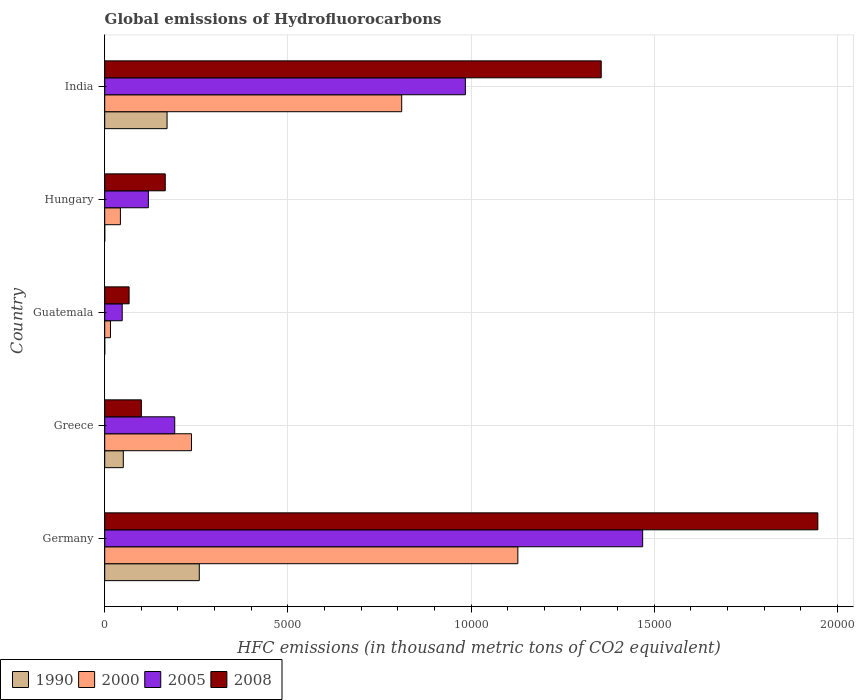How many different coloured bars are there?
Provide a succinct answer. 4. How many groups of bars are there?
Offer a very short reply. 5. What is the global emissions of Hydrofluorocarbons in 2005 in India?
Keep it short and to the point. 9845.2. Across all countries, what is the maximum global emissions of Hydrofluorocarbons in 1990?
Make the answer very short. 2581.5. In which country was the global emissions of Hydrofluorocarbons in 2005 maximum?
Offer a very short reply. Germany. In which country was the global emissions of Hydrofluorocarbons in 2005 minimum?
Offer a terse response. Guatemala. What is the total global emissions of Hydrofluorocarbons in 2008 in the graph?
Offer a terse response. 3.63e+04. What is the difference between the global emissions of Hydrofluorocarbons in 1990 in Guatemala and that in India?
Your answer should be compact. -1702. What is the difference between the global emissions of Hydrofluorocarbons in 2008 in Greece and the global emissions of Hydrofluorocarbons in 2000 in Guatemala?
Ensure brevity in your answer.  842.7. What is the average global emissions of Hydrofluorocarbons in 2005 per country?
Give a very brief answer. 5622.08. What is the difference between the global emissions of Hydrofluorocarbons in 1990 and global emissions of Hydrofluorocarbons in 2008 in Guatemala?
Offer a terse response. -665.7. What is the ratio of the global emissions of Hydrofluorocarbons in 2000 in Germany to that in India?
Offer a terse response. 1.39. Is the global emissions of Hydrofluorocarbons in 2000 in Greece less than that in India?
Offer a very short reply. Yes. Is the difference between the global emissions of Hydrofluorocarbons in 1990 in Germany and India greater than the difference between the global emissions of Hydrofluorocarbons in 2008 in Germany and India?
Your answer should be very brief. No. What is the difference between the highest and the second highest global emissions of Hydrofluorocarbons in 1990?
Give a very brief answer. 879.4. What is the difference between the highest and the lowest global emissions of Hydrofluorocarbons in 2008?
Your answer should be very brief. 1.88e+04. In how many countries, is the global emissions of Hydrofluorocarbons in 2005 greater than the average global emissions of Hydrofluorocarbons in 2005 taken over all countries?
Your answer should be very brief. 2. Is the sum of the global emissions of Hydrofluorocarbons in 2005 in Germany and Greece greater than the maximum global emissions of Hydrofluorocarbons in 1990 across all countries?
Keep it short and to the point. Yes. Is it the case that in every country, the sum of the global emissions of Hydrofluorocarbons in 2000 and global emissions of Hydrofluorocarbons in 1990 is greater than the sum of global emissions of Hydrofluorocarbons in 2008 and global emissions of Hydrofluorocarbons in 2005?
Provide a short and direct response. No. What does the 4th bar from the top in Germany represents?
Offer a terse response. 1990. What does the 1st bar from the bottom in India represents?
Keep it short and to the point. 1990. Is it the case that in every country, the sum of the global emissions of Hydrofluorocarbons in 1990 and global emissions of Hydrofluorocarbons in 2005 is greater than the global emissions of Hydrofluorocarbons in 2000?
Keep it short and to the point. Yes. Are all the bars in the graph horizontal?
Offer a terse response. Yes. How many countries are there in the graph?
Offer a terse response. 5. Are the values on the major ticks of X-axis written in scientific E-notation?
Your answer should be very brief. No. Does the graph contain any zero values?
Your answer should be compact. No. Does the graph contain grids?
Keep it short and to the point. Yes. Where does the legend appear in the graph?
Your answer should be compact. Bottom left. How are the legend labels stacked?
Ensure brevity in your answer.  Horizontal. What is the title of the graph?
Make the answer very short. Global emissions of Hydrofluorocarbons. Does "2015" appear as one of the legend labels in the graph?
Keep it short and to the point. No. What is the label or title of the X-axis?
Give a very brief answer. HFC emissions (in thousand metric tons of CO2 equivalent). What is the label or title of the Y-axis?
Ensure brevity in your answer.  Country. What is the HFC emissions (in thousand metric tons of CO2 equivalent) of 1990 in Germany?
Make the answer very short. 2581.5. What is the HFC emissions (in thousand metric tons of CO2 equivalent) of 2000 in Germany?
Provide a short and direct response. 1.13e+04. What is the HFC emissions (in thousand metric tons of CO2 equivalent) of 2005 in Germany?
Ensure brevity in your answer.  1.47e+04. What is the HFC emissions (in thousand metric tons of CO2 equivalent) of 2008 in Germany?
Offer a terse response. 1.95e+04. What is the HFC emissions (in thousand metric tons of CO2 equivalent) in 1990 in Greece?
Ensure brevity in your answer.  507.2. What is the HFC emissions (in thousand metric tons of CO2 equivalent) of 2000 in Greece?
Give a very brief answer. 2368.4. What is the HFC emissions (in thousand metric tons of CO2 equivalent) of 2005 in Greece?
Ensure brevity in your answer.  1911.4. What is the HFC emissions (in thousand metric tons of CO2 equivalent) of 2008 in Greece?
Give a very brief answer. 1000.3. What is the HFC emissions (in thousand metric tons of CO2 equivalent) of 1990 in Guatemala?
Your answer should be compact. 0.1. What is the HFC emissions (in thousand metric tons of CO2 equivalent) of 2000 in Guatemala?
Your response must be concise. 157.6. What is the HFC emissions (in thousand metric tons of CO2 equivalent) in 2005 in Guatemala?
Make the answer very short. 477.8. What is the HFC emissions (in thousand metric tons of CO2 equivalent) of 2008 in Guatemala?
Keep it short and to the point. 665.8. What is the HFC emissions (in thousand metric tons of CO2 equivalent) of 2000 in Hungary?
Your answer should be very brief. 428.2. What is the HFC emissions (in thousand metric tons of CO2 equivalent) in 2005 in Hungary?
Offer a terse response. 1191.4. What is the HFC emissions (in thousand metric tons of CO2 equivalent) of 2008 in Hungary?
Your answer should be compact. 1652.9. What is the HFC emissions (in thousand metric tons of CO2 equivalent) in 1990 in India?
Provide a succinct answer. 1702.1. What is the HFC emissions (in thousand metric tons of CO2 equivalent) of 2000 in India?
Your answer should be compact. 8107.2. What is the HFC emissions (in thousand metric tons of CO2 equivalent) of 2005 in India?
Provide a short and direct response. 9845.2. What is the HFC emissions (in thousand metric tons of CO2 equivalent) in 2008 in India?
Offer a very short reply. 1.36e+04. Across all countries, what is the maximum HFC emissions (in thousand metric tons of CO2 equivalent) in 1990?
Your answer should be compact. 2581.5. Across all countries, what is the maximum HFC emissions (in thousand metric tons of CO2 equivalent) in 2000?
Give a very brief answer. 1.13e+04. Across all countries, what is the maximum HFC emissions (in thousand metric tons of CO2 equivalent) in 2005?
Ensure brevity in your answer.  1.47e+04. Across all countries, what is the maximum HFC emissions (in thousand metric tons of CO2 equivalent) in 2008?
Provide a succinct answer. 1.95e+04. Across all countries, what is the minimum HFC emissions (in thousand metric tons of CO2 equivalent) in 2000?
Your response must be concise. 157.6. Across all countries, what is the minimum HFC emissions (in thousand metric tons of CO2 equivalent) in 2005?
Ensure brevity in your answer.  477.8. Across all countries, what is the minimum HFC emissions (in thousand metric tons of CO2 equivalent) in 2008?
Offer a terse response. 665.8. What is the total HFC emissions (in thousand metric tons of CO2 equivalent) in 1990 in the graph?
Keep it short and to the point. 4791. What is the total HFC emissions (in thousand metric tons of CO2 equivalent) of 2000 in the graph?
Your answer should be very brief. 2.23e+04. What is the total HFC emissions (in thousand metric tons of CO2 equivalent) of 2005 in the graph?
Ensure brevity in your answer.  2.81e+04. What is the total HFC emissions (in thousand metric tons of CO2 equivalent) in 2008 in the graph?
Your response must be concise. 3.63e+04. What is the difference between the HFC emissions (in thousand metric tons of CO2 equivalent) in 1990 in Germany and that in Greece?
Your answer should be compact. 2074.3. What is the difference between the HFC emissions (in thousand metric tons of CO2 equivalent) in 2000 in Germany and that in Greece?
Keep it short and to the point. 8909.2. What is the difference between the HFC emissions (in thousand metric tons of CO2 equivalent) in 2005 in Germany and that in Greece?
Offer a terse response. 1.28e+04. What is the difference between the HFC emissions (in thousand metric tons of CO2 equivalent) in 2008 in Germany and that in Greece?
Keep it short and to the point. 1.85e+04. What is the difference between the HFC emissions (in thousand metric tons of CO2 equivalent) in 1990 in Germany and that in Guatemala?
Offer a terse response. 2581.4. What is the difference between the HFC emissions (in thousand metric tons of CO2 equivalent) of 2000 in Germany and that in Guatemala?
Your answer should be compact. 1.11e+04. What is the difference between the HFC emissions (in thousand metric tons of CO2 equivalent) of 2005 in Germany and that in Guatemala?
Ensure brevity in your answer.  1.42e+04. What is the difference between the HFC emissions (in thousand metric tons of CO2 equivalent) of 2008 in Germany and that in Guatemala?
Make the answer very short. 1.88e+04. What is the difference between the HFC emissions (in thousand metric tons of CO2 equivalent) of 1990 in Germany and that in Hungary?
Your answer should be compact. 2581.4. What is the difference between the HFC emissions (in thousand metric tons of CO2 equivalent) in 2000 in Germany and that in Hungary?
Offer a terse response. 1.08e+04. What is the difference between the HFC emissions (in thousand metric tons of CO2 equivalent) in 2005 in Germany and that in Hungary?
Your answer should be very brief. 1.35e+04. What is the difference between the HFC emissions (in thousand metric tons of CO2 equivalent) of 2008 in Germany and that in Hungary?
Your response must be concise. 1.78e+04. What is the difference between the HFC emissions (in thousand metric tons of CO2 equivalent) in 1990 in Germany and that in India?
Your response must be concise. 879.4. What is the difference between the HFC emissions (in thousand metric tons of CO2 equivalent) of 2000 in Germany and that in India?
Your response must be concise. 3170.4. What is the difference between the HFC emissions (in thousand metric tons of CO2 equivalent) of 2005 in Germany and that in India?
Provide a short and direct response. 4839.4. What is the difference between the HFC emissions (in thousand metric tons of CO2 equivalent) of 2008 in Germany and that in India?
Provide a succinct answer. 5913.1. What is the difference between the HFC emissions (in thousand metric tons of CO2 equivalent) of 1990 in Greece and that in Guatemala?
Make the answer very short. 507.1. What is the difference between the HFC emissions (in thousand metric tons of CO2 equivalent) of 2000 in Greece and that in Guatemala?
Your response must be concise. 2210.8. What is the difference between the HFC emissions (in thousand metric tons of CO2 equivalent) in 2005 in Greece and that in Guatemala?
Ensure brevity in your answer.  1433.6. What is the difference between the HFC emissions (in thousand metric tons of CO2 equivalent) in 2008 in Greece and that in Guatemala?
Provide a short and direct response. 334.5. What is the difference between the HFC emissions (in thousand metric tons of CO2 equivalent) in 1990 in Greece and that in Hungary?
Provide a short and direct response. 507.1. What is the difference between the HFC emissions (in thousand metric tons of CO2 equivalent) of 2000 in Greece and that in Hungary?
Your answer should be compact. 1940.2. What is the difference between the HFC emissions (in thousand metric tons of CO2 equivalent) in 2005 in Greece and that in Hungary?
Provide a short and direct response. 720. What is the difference between the HFC emissions (in thousand metric tons of CO2 equivalent) of 2008 in Greece and that in Hungary?
Provide a succinct answer. -652.6. What is the difference between the HFC emissions (in thousand metric tons of CO2 equivalent) in 1990 in Greece and that in India?
Your answer should be very brief. -1194.9. What is the difference between the HFC emissions (in thousand metric tons of CO2 equivalent) of 2000 in Greece and that in India?
Your answer should be compact. -5738.8. What is the difference between the HFC emissions (in thousand metric tons of CO2 equivalent) in 2005 in Greece and that in India?
Offer a terse response. -7933.8. What is the difference between the HFC emissions (in thousand metric tons of CO2 equivalent) of 2008 in Greece and that in India?
Your response must be concise. -1.26e+04. What is the difference between the HFC emissions (in thousand metric tons of CO2 equivalent) of 1990 in Guatemala and that in Hungary?
Provide a succinct answer. 0. What is the difference between the HFC emissions (in thousand metric tons of CO2 equivalent) in 2000 in Guatemala and that in Hungary?
Make the answer very short. -270.6. What is the difference between the HFC emissions (in thousand metric tons of CO2 equivalent) in 2005 in Guatemala and that in Hungary?
Ensure brevity in your answer.  -713.6. What is the difference between the HFC emissions (in thousand metric tons of CO2 equivalent) in 2008 in Guatemala and that in Hungary?
Provide a short and direct response. -987.1. What is the difference between the HFC emissions (in thousand metric tons of CO2 equivalent) of 1990 in Guatemala and that in India?
Ensure brevity in your answer.  -1702. What is the difference between the HFC emissions (in thousand metric tons of CO2 equivalent) in 2000 in Guatemala and that in India?
Ensure brevity in your answer.  -7949.6. What is the difference between the HFC emissions (in thousand metric tons of CO2 equivalent) of 2005 in Guatemala and that in India?
Your answer should be very brief. -9367.4. What is the difference between the HFC emissions (in thousand metric tons of CO2 equivalent) of 2008 in Guatemala and that in India?
Offer a very short reply. -1.29e+04. What is the difference between the HFC emissions (in thousand metric tons of CO2 equivalent) in 1990 in Hungary and that in India?
Offer a terse response. -1702. What is the difference between the HFC emissions (in thousand metric tons of CO2 equivalent) in 2000 in Hungary and that in India?
Provide a succinct answer. -7679. What is the difference between the HFC emissions (in thousand metric tons of CO2 equivalent) in 2005 in Hungary and that in India?
Your response must be concise. -8653.8. What is the difference between the HFC emissions (in thousand metric tons of CO2 equivalent) of 2008 in Hungary and that in India?
Your answer should be compact. -1.19e+04. What is the difference between the HFC emissions (in thousand metric tons of CO2 equivalent) of 1990 in Germany and the HFC emissions (in thousand metric tons of CO2 equivalent) of 2000 in Greece?
Make the answer very short. 213.1. What is the difference between the HFC emissions (in thousand metric tons of CO2 equivalent) of 1990 in Germany and the HFC emissions (in thousand metric tons of CO2 equivalent) of 2005 in Greece?
Ensure brevity in your answer.  670.1. What is the difference between the HFC emissions (in thousand metric tons of CO2 equivalent) in 1990 in Germany and the HFC emissions (in thousand metric tons of CO2 equivalent) in 2008 in Greece?
Offer a terse response. 1581.2. What is the difference between the HFC emissions (in thousand metric tons of CO2 equivalent) in 2000 in Germany and the HFC emissions (in thousand metric tons of CO2 equivalent) in 2005 in Greece?
Ensure brevity in your answer.  9366.2. What is the difference between the HFC emissions (in thousand metric tons of CO2 equivalent) of 2000 in Germany and the HFC emissions (in thousand metric tons of CO2 equivalent) of 2008 in Greece?
Your answer should be compact. 1.03e+04. What is the difference between the HFC emissions (in thousand metric tons of CO2 equivalent) in 2005 in Germany and the HFC emissions (in thousand metric tons of CO2 equivalent) in 2008 in Greece?
Your answer should be very brief. 1.37e+04. What is the difference between the HFC emissions (in thousand metric tons of CO2 equivalent) in 1990 in Germany and the HFC emissions (in thousand metric tons of CO2 equivalent) in 2000 in Guatemala?
Your answer should be very brief. 2423.9. What is the difference between the HFC emissions (in thousand metric tons of CO2 equivalent) of 1990 in Germany and the HFC emissions (in thousand metric tons of CO2 equivalent) of 2005 in Guatemala?
Give a very brief answer. 2103.7. What is the difference between the HFC emissions (in thousand metric tons of CO2 equivalent) in 1990 in Germany and the HFC emissions (in thousand metric tons of CO2 equivalent) in 2008 in Guatemala?
Keep it short and to the point. 1915.7. What is the difference between the HFC emissions (in thousand metric tons of CO2 equivalent) of 2000 in Germany and the HFC emissions (in thousand metric tons of CO2 equivalent) of 2005 in Guatemala?
Provide a short and direct response. 1.08e+04. What is the difference between the HFC emissions (in thousand metric tons of CO2 equivalent) of 2000 in Germany and the HFC emissions (in thousand metric tons of CO2 equivalent) of 2008 in Guatemala?
Your response must be concise. 1.06e+04. What is the difference between the HFC emissions (in thousand metric tons of CO2 equivalent) of 2005 in Germany and the HFC emissions (in thousand metric tons of CO2 equivalent) of 2008 in Guatemala?
Offer a very short reply. 1.40e+04. What is the difference between the HFC emissions (in thousand metric tons of CO2 equivalent) in 1990 in Germany and the HFC emissions (in thousand metric tons of CO2 equivalent) in 2000 in Hungary?
Make the answer very short. 2153.3. What is the difference between the HFC emissions (in thousand metric tons of CO2 equivalent) in 1990 in Germany and the HFC emissions (in thousand metric tons of CO2 equivalent) in 2005 in Hungary?
Provide a short and direct response. 1390.1. What is the difference between the HFC emissions (in thousand metric tons of CO2 equivalent) of 1990 in Germany and the HFC emissions (in thousand metric tons of CO2 equivalent) of 2008 in Hungary?
Offer a very short reply. 928.6. What is the difference between the HFC emissions (in thousand metric tons of CO2 equivalent) in 2000 in Germany and the HFC emissions (in thousand metric tons of CO2 equivalent) in 2005 in Hungary?
Ensure brevity in your answer.  1.01e+04. What is the difference between the HFC emissions (in thousand metric tons of CO2 equivalent) of 2000 in Germany and the HFC emissions (in thousand metric tons of CO2 equivalent) of 2008 in Hungary?
Your response must be concise. 9624.7. What is the difference between the HFC emissions (in thousand metric tons of CO2 equivalent) in 2005 in Germany and the HFC emissions (in thousand metric tons of CO2 equivalent) in 2008 in Hungary?
Provide a succinct answer. 1.30e+04. What is the difference between the HFC emissions (in thousand metric tons of CO2 equivalent) in 1990 in Germany and the HFC emissions (in thousand metric tons of CO2 equivalent) in 2000 in India?
Offer a terse response. -5525.7. What is the difference between the HFC emissions (in thousand metric tons of CO2 equivalent) of 1990 in Germany and the HFC emissions (in thousand metric tons of CO2 equivalent) of 2005 in India?
Provide a succinct answer. -7263.7. What is the difference between the HFC emissions (in thousand metric tons of CO2 equivalent) in 1990 in Germany and the HFC emissions (in thousand metric tons of CO2 equivalent) in 2008 in India?
Make the answer very short. -1.10e+04. What is the difference between the HFC emissions (in thousand metric tons of CO2 equivalent) of 2000 in Germany and the HFC emissions (in thousand metric tons of CO2 equivalent) of 2005 in India?
Provide a succinct answer. 1432.4. What is the difference between the HFC emissions (in thousand metric tons of CO2 equivalent) of 2000 in Germany and the HFC emissions (in thousand metric tons of CO2 equivalent) of 2008 in India?
Your answer should be compact. -2276.1. What is the difference between the HFC emissions (in thousand metric tons of CO2 equivalent) in 2005 in Germany and the HFC emissions (in thousand metric tons of CO2 equivalent) in 2008 in India?
Your answer should be compact. 1130.9. What is the difference between the HFC emissions (in thousand metric tons of CO2 equivalent) of 1990 in Greece and the HFC emissions (in thousand metric tons of CO2 equivalent) of 2000 in Guatemala?
Ensure brevity in your answer.  349.6. What is the difference between the HFC emissions (in thousand metric tons of CO2 equivalent) in 1990 in Greece and the HFC emissions (in thousand metric tons of CO2 equivalent) in 2005 in Guatemala?
Your answer should be very brief. 29.4. What is the difference between the HFC emissions (in thousand metric tons of CO2 equivalent) in 1990 in Greece and the HFC emissions (in thousand metric tons of CO2 equivalent) in 2008 in Guatemala?
Give a very brief answer. -158.6. What is the difference between the HFC emissions (in thousand metric tons of CO2 equivalent) in 2000 in Greece and the HFC emissions (in thousand metric tons of CO2 equivalent) in 2005 in Guatemala?
Your response must be concise. 1890.6. What is the difference between the HFC emissions (in thousand metric tons of CO2 equivalent) of 2000 in Greece and the HFC emissions (in thousand metric tons of CO2 equivalent) of 2008 in Guatemala?
Your answer should be very brief. 1702.6. What is the difference between the HFC emissions (in thousand metric tons of CO2 equivalent) of 2005 in Greece and the HFC emissions (in thousand metric tons of CO2 equivalent) of 2008 in Guatemala?
Your answer should be compact. 1245.6. What is the difference between the HFC emissions (in thousand metric tons of CO2 equivalent) in 1990 in Greece and the HFC emissions (in thousand metric tons of CO2 equivalent) in 2000 in Hungary?
Offer a terse response. 79. What is the difference between the HFC emissions (in thousand metric tons of CO2 equivalent) of 1990 in Greece and the HFC emissions (in thousand metric tons of CO2 equivalent) of 2005 in Hungary?
Make the answer very short. -684.2. What is the difference between the HFC emissions (in thousand metric tons of CO2 equivalent) of 1990 in Greece and the HFC emissions (in thousand metric tons of CO2 equivalent) of 2008 in Hungary?
Provide a short and direct response. -1145.7. What is the difference between the HFC emissions (in thousand metric tons of CO2 equivalent) in 2000 in Greece and the HFC emissions (in thousand metric tons of CO2 equivalent) in 2005 in Hungary?
Your answer should be compact. 1177. What is the difference between the HFC emissions (in thousand metric tons of CO2 equivalent) in 2000 in Greece and the HFC emissions (in thousand metric tons of CO2 equivalent) in 2008 in Hungary?
Keep it short and to the point. 715.5. What is the difference between the HFC emissions (in thousand metric tons of CO2 equivalent) of 2005 in Greece and the HFC emissions (in thousand metric tons of CO2 equivalent) of 2008 in Hungary?
Make the answer very short. 258.5. What is the difference between the HFC emissions (in thousand metric tons of CO2 equivalent) in 1990 in Greece and the HFC emissions (in thousand metric tons of CO2 equivalent) in 2000 in India?
Offer a terse response. -7600. What is the difference between the HFC emissions (in thousand metric tons of CO2 equivalent) of 1990 in Greece and the HFC emissions (in thousand metric tons of CO2 equivalent) of 2005 in India?
Ensure brevity in your answer.  -9338. What is the difference between the HFC emissions (in thousand metric tons of CO2 equivalent) of 1990 in Greece and the HFC emissions (in thousand metric tons of CO2 equivalent) of 2008 in India?
Offer a very short reply. -1.30e+04. What is the difference between the HFC emissions (in thousand metric tons of CO2 equivalent) of 2000 in Greece and the HFC emissions (in thousand metric tons of CO2 equivalent) of 2005 in India?
Give a very brief answer. -7476.8. What is the difference between the HFC emissions (in thousand metric tons of CO2 equivalent) of 2000 in Greece and the HFC emissions (in thousand metric tons of CO2 equivalent) of 2008 in India?
Your answer should be compact. -1.12e+04. What is the difference between the HFC emissions (in thousand metric tons of CO2 equivalent) of 2005 in Greece and the HFC emissions (in thousand metric tons of CO2 equivalent) of 2008 in India?
Offer a very short reply. -1.16e+04. What is the difference between the HFC emissions (in thousand metric tons of CO2 equivalent) in 1990 in Guatemala and the HFC emissions (in thousand metric tons of CO2 equivalent) in 2000 in Hungary?
Keep it short and to the point. -428.1. What is the difference between the HFC emissions (in thousand metric tons of CO2 equivalent) in 1990 in Guatemala and the HFC emissions (in thousand metric tons of CO2 equivalent) in 2005 in Hungary?
Provide a succinct answer. -1191.3. What is the difference between the HFC emissions (in thousand metric tons of CO2 equivalent) of 1990 in Guatemala and the HFC emissions (in thousand metric tons of CO2 equivalent) of 2008 in Hungary?
Ensure brevity in your answer.  -1652.8. What is the difference between the HFC emissions (in thousand metric tons of CO2 equivalent) in 2000 in Guatemala and the HFC emissions (in thousand metric tons of CO2 equivalent) in 2005 in Hungary?
Make the answer very short. -1033.8. What is the difference between the HFC emissions (in thousand metric tons of CO2 equivalent) of 2000 in Guatemala and the HFC emissions (in thousand metric tons of CO2 equivalent) of 2008 in Hungary?
Your response must be concise. -1495.3. What is the difference between the HFC emissions (in thousand metric tons of CO2 equivalent) in 2005 in Guatemala and the HFC emissions (in thousand metric tons of CO2 equivalent) in 2008 in Hungary?
Your answer should be very brief. -1175.1. What is the difference between the HFC emissions (in thousand metric tons of CO2 equivalent) in 1990 in Guatemala and the HFC emissions (in thousand metric tons of CO2 equivalent) in 2000 in India?
Offer a terse response. -8107.1. What is the difference between the HFC emissions (in thousand metric tons of CO2 equivalent) of 1990 in Guatemala and the HFC emissions (in thousand metric tons of CO2 equivalent) of 2005 in India?
Ensure brevity in your answer.  -9845.1. What is the difference between the HFC emissions (in thousand metric tons of CO2 equivalent) of 1990 in Guatemala and the HFC emissions (in thousand metric tons of CO2 equivalent) of 2008 in India?
Provide a succinct answer. -1.36e+04. What is the difference between the HFC emissions (in thousand metric tons of CO2 equivalent) of 2000 in Guatemala and the HFC emissions (in thousand metric tons of CO2 equivalent) of 2005 in India?
Offer a terse response. -9687.6. What is the difference between the HFC emissions (in thousand metric tons of CO2 equivalent) in 2000 in Guatemala and the HFC emissions (in thousand metric tons of CO2 equivalent) in 2008 in India?
Offer a very short reply. -1.34e+04. What is the difference between the HFC emissions (in thousand metric tons of CO2 equivalent) of 2005 in Guatemala and the HFC emissions (in thousand metric tons of CO2 equivalent) of 2008 in India?
Give a very brief answer. -1.31e+04. What is the difference between the HFC emissions (in thousand metric tons of CO2 equivalent) in 1990 in Hungary and the HFC emissions (in thousand metric tons of CO2 equivalent) in 2000 in India?
Your answer should be very brief. -8107.1. What is the difference between the HFC emissions (in thousand metric tons of CO2 equivalent) of 1990 in Hungary and the HFC emissions (in thousand metric tons of CO2 equivalent) of 2005 in India?
Provide a succinct answer. -9845.1. What is the difference between the HFC emissions (in thousand metric tons of CO2 equivalent) in 1990 in Hungary and the HFC emissions (in thousand metric tons of CO2 equivalent) in 2008 in India?
Your response must be concise. -1.36e+04. What is the difference between the HFC emissions (in thousand metric tons of CO2 equivalent) of 2000 in Hungary and the HFC emissions (in thousand metric tons of CO2 equivalent) of 2005 in India?
Keep it short and to the point. -9417. What is the difference between the HFC emissions (in thousand metric tons of CO2 equivalent) of 2000 in Hungary and the HFC emissions (in thousand metric tons of CO2 equivalent) of 2008 in India?
Provide a short and direct response. -1.31e+04. What is the difference between the HFC emissions (in thousand metric tons of CO2 equivalent) of 2005 in Hungary and the HFC emissions (in thousand metric tons of CO2 equivalent) of 2008 in India?
Give a very brief answer. -1.24e+04. What is the average HFC emissions (in thousand metric tons of CO2 equivalent) in 1990 per country?
Your answer should be compact. 958.2. What is the average HFC emissions (in thousand metric tons of CO2 equivalent) of 2000 per country?
Offer a terse response. 4467.8. What is the average HFC emissions (in thousand metric tons of CO2 equivalent) in 2005 per country?
Give a very brief answer. 5622.08. What is the average HFC emissions (in thousand metric tons of CO2 equivalent) of 2008 per country?
Keep it short and to the point. 7267.9. What is the difference between the HFC emissions (in thousand metric tons of CO2 equivalent) of 1990 and HFC emissions (in thousand metric tons of CO2 equivalent) of 2000 in Germany?
Your answer should be compact. -8696.1. What is the difference between the HFC emissions (in thousand metric tons of CO2 equivalent) in 1990 and HFC emissions (in thousand metric tons of CO2 equivalent) in 2005 in Germany?
Make the answer very short. -1.21e+04. What is the difference between the HFC emissions (in thousand metric tons of CO2 equivalent) in 1990 and HFC emissions (in thousand metric tons of CO2 equivalent) in 2008 in Germany?
Provide a short and direct response. -1.69e+04. What is the difference between the HFC emissions (in thousand metric tons of CO2 equivalent) of 2000 and HFC emissions (in thousand metric tons of CO2 equivalent) of 2005 in Germany?
Your answer should be very brief. -3407. What is the difference between the HFC emissions (in thousand metric tons of CO2 equivalent) in 2000 and HFC emissions (in thousand metric tons of CO2 equivalent) in 2008 in Germany?
Offer a very short reply. -8189.2. What is the difference between the HFC emissions (in thousand metric tons of CO2 equivalent) of 2005 and HFC emissions (in thousand metric tons of CO2 equivalent) of 2008 in Germany?
Offer a very short reply. -4782.2. What is the difference between the HFC emissions (in thousand metric tons of CO2 equivalent) of 1990 and HFC emissions (in thousand metric tons of CO2 equivalent) of 2000 in Greece?
Offer a very short reply. -1861.2. What is the difference between the HFC emissions (in thousand metric tons of CO2 equivalent) in 1990 and HFC emissions (in thousand metric tons of CO2 equivalent) in 2005 in Greece?
Keep it short and to the point. -1404.2. What is the difference between the HFC emissions (in thousand metric tons of CO2 equivalent) in 1990 and HFC emissions (in thousand metric tons of CO2 equivalent) in 2008 in Greece?
Make the answer very short. -493.1. What is the difference between the HFC emissions (in thousand metric tons of CO2 equivalent) of 2000 and HFC emissions (in thousand metric tons of CO2 equivalent) of 2005 in Greece?
Make the answer very short. 457. What is the difference between the HFC emissions (in thousand metric tons of CO2 equivalent) in 2000 and HFC emissions (in thousand metric tons of CO2 equivalent) in 2008 in Greece?
Your answer should be very brief. 1368.1. What is the difference between the HFC emissions (in thousand metric tons of CO2 equivalent) of 2005 and HFC emissions (in thousand metric tons of CO2 equivalent) of 2008 in Greece?
Your response must be concise. 911.1. What is the difference between the HFC emissions (in thousand metric tons of CO2 equivalent) of 1990 and HFC emissions (in thousand metric tons of CO2 equivalent) of 2000 in Guatemala?
Make the answer very short. -157.5. What is the difference between the HFC emissions (in thousand metric tons of CO2 equivalent) of 1990 and HFC emissions (in thousand metric tons of CO2 equivalent) of 2005 in Guatemala?
Provide a short and direct response. -477.7. What is the difference between the HFC emissions (in thousand metric tons of CO2 equivalent) in 1990 and HFC emissions (in thousand metric tons of CO2 equivalent) in 2008 in Guatemala?
Your answer should be very brief. -665.7. What is the difference between the HFC emissions (in thousand metric tons of CO2 equivalent) in 2000 and HFC emissions (in thousand metric tons of CO2 equivalent) in 2005 in Guatemala?
Give a very brief answer. -320.2. What is the difference between the HFC emissions (in thousand metric tons of CO2 equivalent) of 2000 and HFC emissions (in thousand metric tons of CO2 equivalent) of 2008 in Guatemala?
Provide a succinct answer. -508.2. What is the difference between the HFC emissions (in thousand metric tons of CO2 equivalent) of 2005 and HFC emissions (in thousand metric tons of CO2 equivalent) of 2008 in Guatemala?
Your response must be concise. -188. What is the difference between the HFC emissions (in thousand metric tons of CO2 equivalent) of 1990 and HFC emissions (in thousand metric tons of CO2 equivalent) of 2000 in Hungary?
Offer a very short reply. -428.1. What is the difference between the HFC emissions (in thousand metric tons of CO2 equivalent) of 1990 and HFC emissions (in thousand metric tons of CO2 equivalent) of 2005 in Hungary?
Give a very brief answer. -1191.3. What is the difference between the HFC emissions (in thousand metric tons of CO2 equivalent) of 1990 and HFC emissions (in thousand metric tons of CO2 equivalent) of 2008 in Hungary?
Keep it short and to the point. -1652.8. What is the difference between the HFC emissions (in thousand metric tons of CO2 equivalent) of 2000 and HFC emissions (in thousand metric tons of CO2 equivalent) of 2005 in Hungary?
Your response must be concise. -763.2. What is the difference between the HFC emissions (in thousand metric tons of CO2 equivalent) in 2000 and HFC emissions (in thousand metric tons of CO2 equivalent) in 2008 in Hungary?
Offer a very short reply. -1224.7. What is the difference between the HFC emissions (in thousand metric tons of CO2 equivalent) of 2005 and HFC emissions (in thousand metric tons of CO2 equivalent) of 2008 in Hungary?
Offer a very short reply. -461.5. What is the difference between the HFC emissions (in thousand metric tons of CO2 equivalent) in 1990 and HFC emissions (in thousand metric tons of CO2 equivalent) in 2000 in India?
Make the answer very short. -6405.1. What is the difference between the HFC emissions (in thousand metric tons of CO2 equivalent) in 1990 and HFC emissions (in thousand metric tons of CO2 equivalent) in 2005 in India?
Offer a very short reply. -8143.1. What is the difference between the HFC emissions (in thousand metric tons of CO2 equivalent) of 1990 and HFC emissions (in thousand metric tons of CO2 equivalent) of 2008 in India?
Keep it short and to the point. -1.19e+04. What is the difference between the HFC emissions (in thousand metric tons of CO2 equivalent) in 2000 and HFC emissions (in thousand metric tons of CO2 equivalent) in 2005 in India?
Ensure brevity in your answer.  -1738. What is the difference between the HFC emissions (in thousand metric tons of CO2 equivalent) of 2000 and HFC emissions (in thousand metric tons of CO2 equivalent) of 2008 in India?
Provide a succinct answer. -5446.5. What is the difference between the HFC emissions (in thousand metric tons of CO2 equivalent) of 2005 and HFC emissions (in thousand metric tons of CO2 equivalent) of 2008 in India?
Provide a succinct answer. -3708.5. What is the ratio of the HFC emissions (in thousand metric tons of CO2 equivalent) of 1990 in Germany to that in Greece?
Your answer should be very brief. 5.09. What is the ratio of the HFC emissions (in thousand metric tons of CO2 equivalent) of 2000 in Germany to that in Greece?
Keep it short and to the point. 4.76. What is the ratio of the HFC emissions (in thousand metric tons of CO2 equivalent) in 2005 in Germany to that in Greece?
Ensure brevity in your answer.  7.68. What is the ratio of the HFC emissions (in thousand metric tons of CO2 equivalent) in 2008 in Germany to that in Greece?
Ensure brevity in your answer.  19.46. What is the ratio of the HFC emissions (in thousand metric tons of CO2 equivalent) in 1990 in Germany to that in Guatemala?
Your response must be concise. 2.58e+04. What is the ratio of the HFC emissions (in thousand metric tons of CO2 equivalent) of 2000 in Germany to that in Guatemala?
Provide a short and direct response. 71.56. What is the ratio of the HFC emissions (in thousand metric tons of CO2 equivalent) in 2005 in Germany to that in Guatemala?
Your answer should be compact. 30.73. What is the ratio of the HFC emissions (in thousand metric tons of CO2 equivalent) in 2008 in Germany to that in Guatemala?
Ensure brevity in your answer.  29.24. What is the ratio of the HFC emissions (in thousand metric tons of CO2 equivalent) of 1990 in Germany to that in Hungary?
Offer a terse response. 2.58e+04. What is the ratio of the HFC emissions (in thousand metric tons of CO2 equivalent) in 2000 in Germany to that in Hungary?
Your response must be concise. 26.34. What is the ratio of the HFC emissions (in thousand metric tons of CO2 equivalent) of 2005 in Germany to that in Hungary?
Your answer should be compact. 12.33. What is the ratio of the HFC emissions (in thousand metric tons of CO2 equivalent) of 2008 in Germany to that in Hungary?
Your answer should be very brief. 11.78. What is the ratio of the HFC emissions (in thousand metric tons of CO2 equivalent) of 1990 in Germany to that in India?
Make the answer very short. 1.52. What is the ratio of the HFC emissions (in thousand metric tons of CO2 equivalent) of 2000 in Germany to that in India?
Ensure brevity in your answer.  1.39. What is the ratio of the HFC emissions (in thousand metric tons of CO2 equivalent) in 2005 in Germany to that in India?
Make the answer very short. 1.49. What is the ratio of the HFC emissions (in thousand metric tons of CO2 equivalent) in 2008 in Germany to that in India?
Your answer should be compact. 1.44. What is the ratio of the HFC emissions (in thousand metric tons of CO2 equivalent) in 1990 in Greece to that in Guatemala?
Keep it short and to the point. 5072. What is the ratio of the HFC emissions (in thousand metric tons of CO2 equivalent) in 2000 in Greece to that in Guatemala?
Provide a succinct answer. 15.03. What is the ratio of the HFC emissions (in thousand metric tons of CO2 equivalent) of 2005 in Greece to that in Guatemala?
Keep it short and to the point. 4. What is the ratio of the HFC emissions (in thousand metric tons of CO2 equivalent) in 2008 in Greece to that in Guatemala?
Your answer should be compact. 1.5. What is the ratio of the HFC emissions (in thousand metric tons of CO2 equivalent) in 1990 in Greece to that in Hungary?
Provide a succinct answer. 5072. What is the ratio of the HFC emissions (in thousand metric tons of CO2 equivalent) of 2000 in Greece to that in Hungary?
Give a very brief answer. 5.53. What is the ratio of the HFC emissions (in thousand metric tons of CO2 equivalent) of 2005 in Greece to that in Hungary?
Ensure brevity in your answer.  1.6. What is the ratio of the HFC emissions (in thousand metric tons of CO2 equivalent) in 2008 in Greece to that in Hungary?
Provide a succinct answer. 0.61. What is the ratio of the HFC emissions (in thousand metric tons of CO2 equivalent) of 1990 in Greece to that in India?
Provide a short and direct response. 0.3. What is the ratio of the HFC emissions (in thousand metric tons of CO2 equivalent) of 2000 in Greece to that in India?
Keep it short and to the point. 0.29. What is the ratio of the HFC emissions (in thousand metric tons of CO2 equivalent) of 2005 in Greece to that in India?
Provide a short and direct response. 0.19. What is the ratio of the HFC emissions (in thousand metric tons of CO2 equivalent) of 2008 in Greece to that in India?
Offer a terse response. 0.07. What is the ratio of the HFC emissions (in thousand metric tons of CO2 equivalent) in 1990 in Guatemala to that in Hungary?
Ensure brevity in your answer.  1. What is the ratio of the HFC emissions (in thousand metric tons of CO2 equivalent) in 2000 in Guatemala to that in Hungary?
Ensure brevity in your answer.  0.37. What is the ratio of the HFC emissions (in thousand metric tons of CO2 equivalent) in 2005 in Guatemala to that in Hungary?
Provide a short and direct response. 0.4. What is the ratio of the HFC emissions (in thousand metric tons of CO2 equivalent) of 2008 in Guatemala to that in Hungary?
Make the answer very short. 0.4. What is the ratio of the HFC emissions (in thousand metric tons of CO2 equivalent) in 1990 in Guatemala to that in India?
Ensure brevity in your answer.  0. What is the ratio of the HFC emissions (in thousand metric tons of CO2 equivalent) of 2000 in Guatemala to that in India?
Ensure brevity in your answer.  0.02. What is the ratio of the HFC emissions (in thousand metric tons of CO2 equivalent) of 2005 in Guatemala to that in India?
Make the answer very short. 0.05. What is the ratio of the HFC emissions (in thousand metric tons of CO2 equivalent) in 2008 in Guatemala to that in India?
Give a very brief answer. 0.05. What is the ratio of the HFC emissions (in thousand metric tons of CO2 equivalent) in 2000 in Hungary to that in India?
Your answer should be very brief. 0.05. What is the ratio of the HFC emissions (in thousand metric tons of CO2 equivalent) of 2005 in Hungary to that in India?
Offer a terse response. 0.12. What is the ratio of the HFC emissions (in thousand metric tons of CO2 equivalent) of 2008 in Hungary to that in India?
Your response must be concise. 0.12. What is the difference between the highest and the second highest HFC emissions (in thousand metric tons of CO2 equivalent) of 1990?
Provide a succinct answer. 879.4. What is the difference between the highest and the second highest HFC emissions (in thousand metric tons of CO2 equivalent) in 2000?
Keep it short and to the point. 3170.4. What is the difference between the highest and the second highest HFC emissions (in thousand metric tons of CO2 equivalent) in 2005?
Make the answer very short. 4839.4. What is the difference between the highest and the second highest HFC emissions (in thousand metric tons of CO2 equivalent) of 2008?
Offer a terse response. 5913.1. What is the difference between the highest and the lowest HFC emissions (in thousand metric tons of CO2 equivalent) in 1990?
Offer a very short reply. 2581.4. What is the difference between the highest and the lowest HFC emissions (in thousand metric tons of CO2 equivalent) in 2000?
Provide a short and direct response. 1.11e+04. What is the difference between the highest and the lowest HFC emissions (in thousand metric tons of CO2 equivalent) of 2005?
Ensure brevity in your answer.  1.42e+04. What is the difference between the highest and the lowest HFC emissions (in thousand metric tons of CO2 equivalent) in 2008?
Make the answer very short. 1.88e+04. 